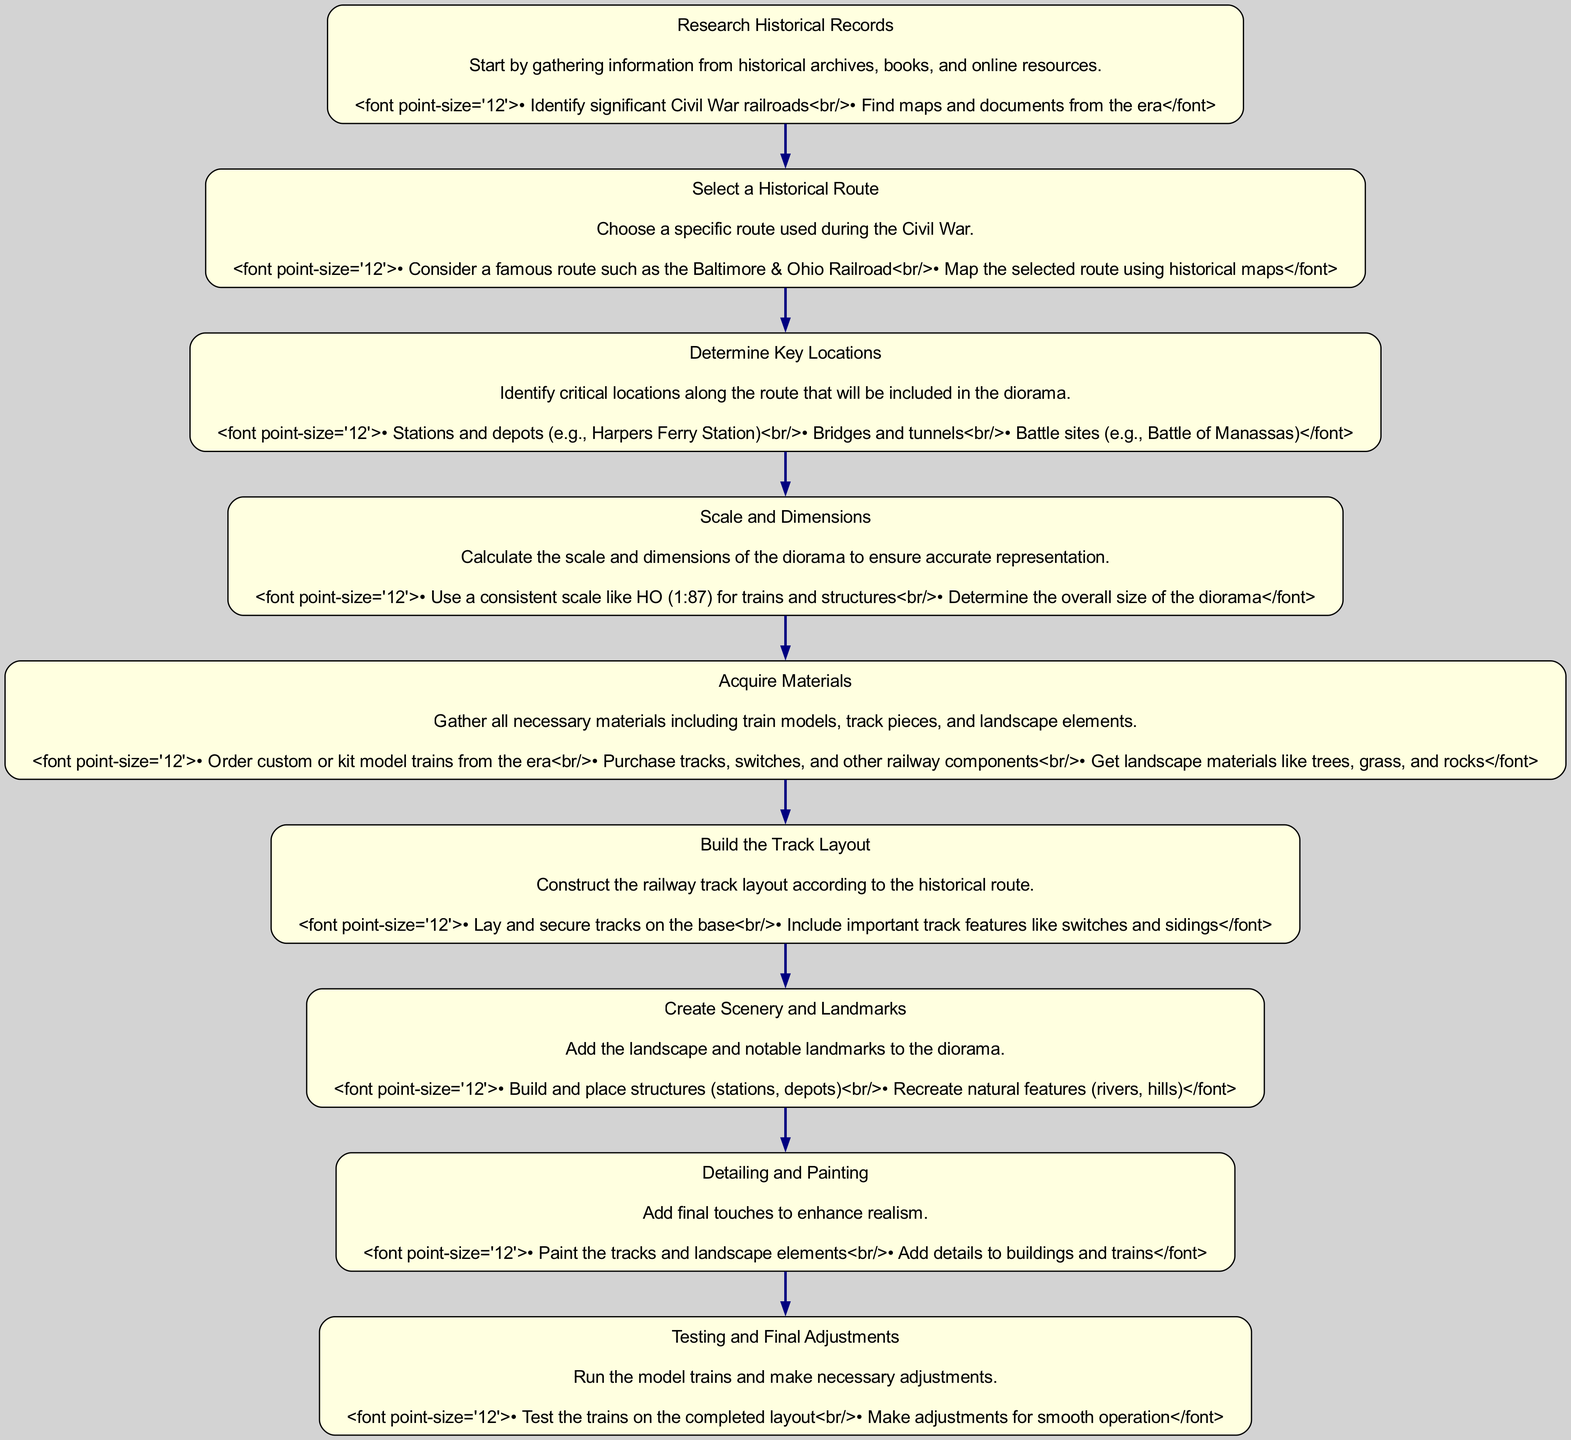What is the first step in the instruction flow? The first step in the instruction flow is "Research Historical Records." This is indicated as the starting point of the flow diagram.
Answer: Research Historical Records How many key locations should be determined? The instruction flow includes the step "Determine Key Locations." While it does not specify an exact number, it lists critical types such as stations, bridges, tunnels, and battle sites, indicating multiple locations to be identified.
Answer: Multiple What significant railroad is mentioned in the selection of a historical route? The significant railroad mentioned is the "Baltimore & Ohio Railroad," which is one of the options when selecting a historical route in the flow.
Answer: Baltimore & Ohio Railroad What follows after acquiring materials? After acquiring materials, the next step is to "Build the Track Layout." This indicates a sequential progression in the instruction flow.
Answer: Build the Track Layout What scale is suggested for the diorama? The suggested scale for the diorama is "HO (1:87)", which ensures consistency in representing trains and structures effectively.
Answer: HO (1:87) What is the purpose of the "Detailing and Painting" step? The purpose of the "Detailing and Painting" step is to add final touches to enhance realism, which helps in making the model more visually relevant.
Answer: Enhance realism How does "Testing and Final Adjustments" relate to the previous step? "Testing and Final Adjustments" directly follows and is dependent on the successful completion of the previous step "Create Scenery and Landmarks," as it involves checking the functionality of the built model.
Answer: Directly follows Which step includes adding landscape materials like trees, grass, and rocks? The step that includes adding landscape materials such as trees, grass, and rocks is "Acquire Materials." This involves gathering all necessary components for the diorama.
Answer: Acquire Materials What are the two categories listed under "Determine Key Locations"? The two categories listed under "Determine Key Locations" are "Stations and depots" and "Battle sites." These categories help in identifying critical locations along the historical route.
Answer: Stations and depots, Battle sites 